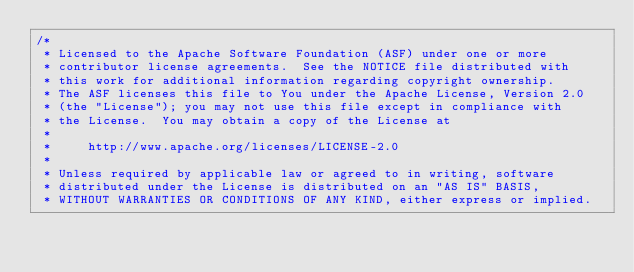Convert code to text. <code><loc_0><loc_0><loc_500><loc_500><_SQL_>/*
 * Licensed to the Apache Software Foundation (ASF) under one or more
 * contributor license agreements.  See the NOTICE file distributed with
 * this work for additional information regarding copyright ownership.
 * The ASF licenses this file to You under the Apache License, Version 2.0
 * (the "License"); you may not use this file except in compliance with
 * the License.  You may obtain a copy of the License at
 *
 *     http://www.apache.org/licenses/LICENSE-2.0
 *
 * Unless required by applicable law or agreed to in writing, software
 * distributed under the License is distributed on an "AS IS" BASIS,
 * WITHOUT WARRANTIES OR CONDITIONS OF ANY KIND, either express or implied.</code> 